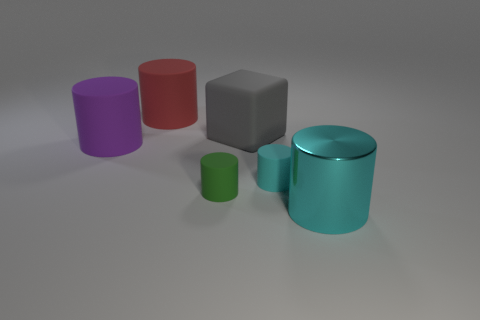Subtract all small rubber cylinders. How many cylinders are left? 3 Add 3 big red cylinders. How many objects exist? 9 Subtract 3 cylinders. How many cylinders are left? 2 Subtract all red blocks. How many cyan cylinders are left? 2 Subtract all cyan cylinders. How many cylinders are left? 3 Subtract all cubes. How many objects are left? 5 Subtract all big red shiny blocks. Subtract all big cyan shiny cylinders. How many objects are left? 5 Add 3 tiny green things. How many tiny green things are left? 4 Add 4 purple shiny cylinders. How many purple shiny cylinders exist? 4 Subtract 0 brown cubes. How many objects are left? 6 